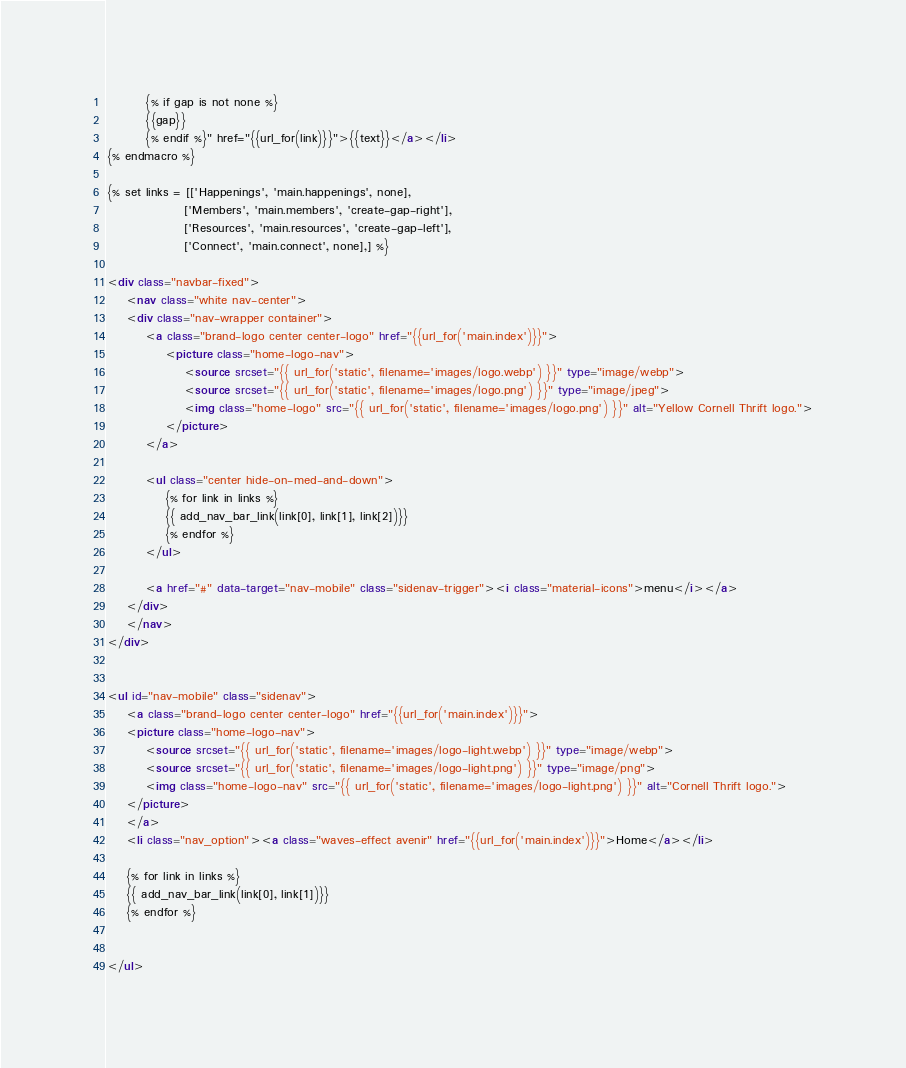Convert code to text. <code><loc_0><loc_0><loc_500><loc_500><_HTML_>        {% if gap is not none %}
        {{gap}}
        {% endif %}" href="{{url_for(link)}}">{{text}}</a></li>
{% endmacro %}

{% set links = [['Happenings', 'main.happenings', none], 
                ['Members', 'main.members', 'create-gap-right'],
                ['Resources', 'main.resources', 'create-gap-left'],
                ['Connect', 'main.connect', none],] %}

<div class="navbar-fixed">
    <nav class="white nav-center">
    <div class="nav-wrapper container">
        <a class="brand-logo center center-logo" href="{{url_for('main.index')}}">  
            <picture class="home-logo-nav">
                <source srcset="{{ url_for('static', filename='images/logo.webp') }}" type="image/webp">
                <source srcset="{{ url_for('static', filename='images/logo.png') }}" type="image/jpeg"> 
                <img class="home-logo" src="{{ url_for('static', filename='images/logo.png') }}" alt="Yellow Cornell Thrift logo.">
            </picture>
        </a>

        <ul class="center hide-on-med-and-down">
            {% for link in links %}
            {{ add_nav_bar_link(link[0], link[1], link[2])}}
            {% endfor %}
        </ul>
        
        <a href="#" data-target="nav-mobile" class="sidenav-trigger"><i class="material-icons">menu</i></a>
    </div>
    </nav>
</div>
       
       
<ul id="nav-mobile" class="sidenav">
    <a class="brand-logo center center-logo" href="{{url_for('main.index')}}">
    <picture class="home-logo-nav">
        <source srcset="{{ url_for('static', filename='images/logo-light.webp') }}" type="image/webp">
        <source srcset="{{ url_for('static', filename='images/logo-light.png') }}" type="image/png"> 
        <img class="home-logo-nav" src="{{ url_for('static', filename='images/logo-light.png') }}" alt="Cornell Thrift logo.">
    </picture>
    </a>
    <li class="nav_option"><a class="waves-effect avenir" href="{{url_for('main.index')}}">Home</a></li>

    {% for link in links %}
    {{ add_nav_bar_link(link[0], link[1])}}
    {% endfor %}


</ul></code> 